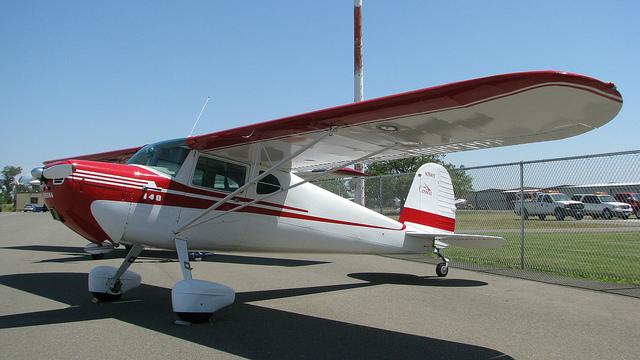How many wheels does the airplane have?
Write a very short answer. 3. What type of plane is this?
Write a very short answer. Small. Is this an airliner?
Concise answer only. No. 